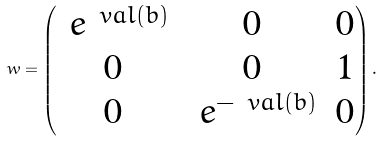Convert formula to latex. <formula><loc_0><loc_0><loc_500><loc_500>\ w = \begin{pmatrix} \ e ^ { \ v a l ( b ) } & 0 & 0 \\ 0 & 0 & 1 \\ 0 & \ e ^ { - \ v a l ( b ) } & 0 \end{pmatrix} .</formula> 